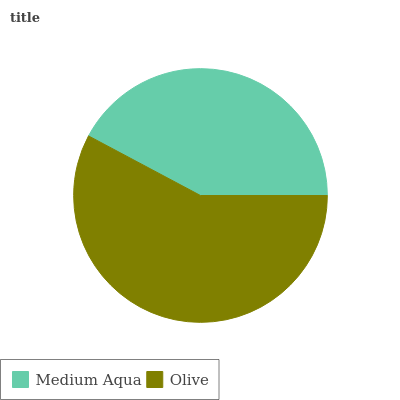Is Medium Aqua the minimum?
Answer yes or no. Yes. Is Olive the maximum?
Answer yes or no. Yes. Is Olive the minimum?
Answer yes or no. No. Is Olive greater than Medium Aqua?
Answer yes or no. Yes. Is Medium Aqua less than Olive?
Answer yes or no. Yes. Is Medium Aqua greater than Olive?
Answer yes or no. No. Is Olive less than Medium Aqua?
Answer yes or no. No. Is Olive the high median?
Answer yes or no. Yes. Is Medium Aqua the low median?
Answer yes or no. Yes. Is Medium Aqua the high median?
Answer yes or no. No. Is Olive the low median?
Answer yes or no. No. 